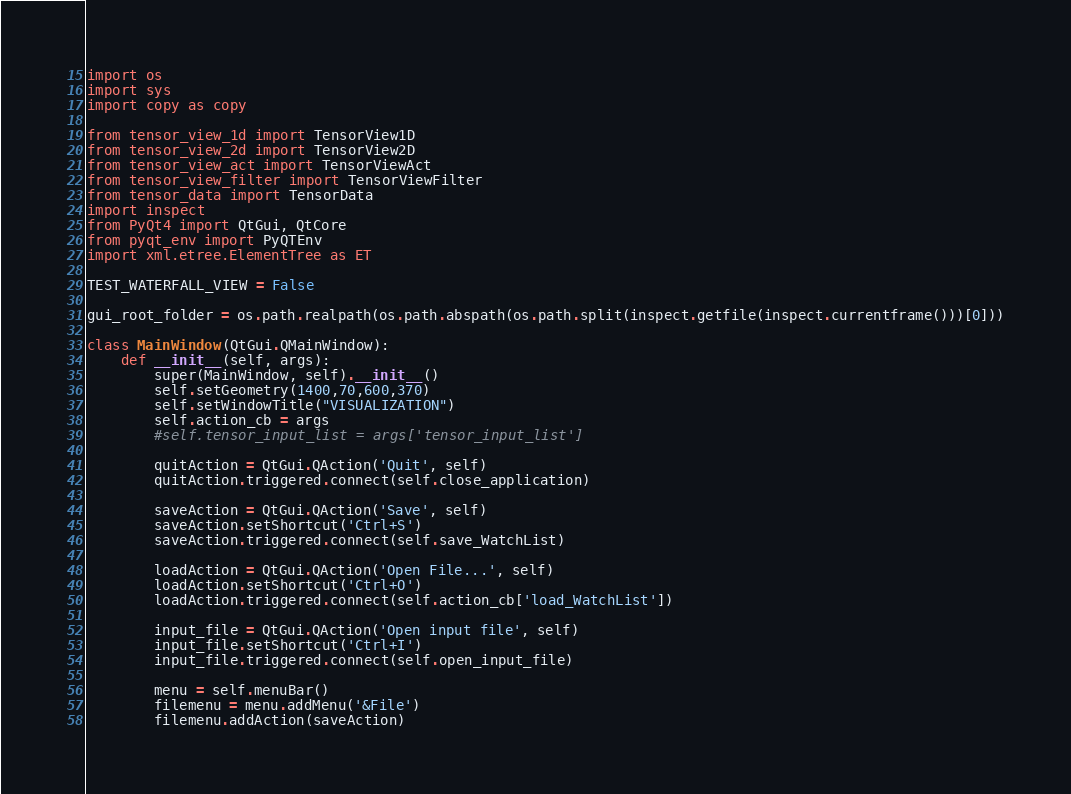Convert code to text. <code><loc_0><loc_0><loc_500><loc_500><_Python_>import os
import sys
import copy as copy

from tensor_view_1d import TensorView1D
from tensor_view_2d import TensorView2D
from tensor_view_act import TensorViewAct
from tensor_view_filter import TensorViewFilter
from tensor_data import TensorData
import inspect
from PyQt4 import QtGui, QtCore
from pyqt_env import PyQTEnv
import xml.etree.ElementTree as ET

TEST_WATERFALL_VIEW = False

gui_root_folder = os.path.realpath(os.path.abspath(os.path.split(inspect.getfile(inspect.currentframe()))[0]))

class MainWindow(QtGui.QMainWindow):
    def __init__(self, args):
        super(MainWindow, self).__init__()
        self.setGeometry(1400,70,600,370)
        self.setWindowTitle("VISUALIZATION")
        self.action_cb = args
        #self.tensor_input_list = args['tensor_input_list']

        quitAction = QtGui.QAction('Quit', self)
        quitAction.triggered.connect(self.close_application)

        saveAction = QtGui.QAction('Save', self)
        saveAction.setShortcut('Ctrl+S')
        saveAction.triggered.connect(self.save_WatchList)

        loadAction = QtGui.QAction('Open File...', self)
        loadAction.setShortcut('Ctrl+O')
        loadAction.triggered.connect(self.action_cb['load_WatchList'])

        input_file = QtGui.QAction('Open input file', self)
        input_file.setShortcut('Ctrl+I')
        input_file.triggered.connect(self.open_input_file)

        menu = self.menuBar()
        filemenu = menu.addMenu('&File')
        filemenu.addAction(saveAction)</code> 